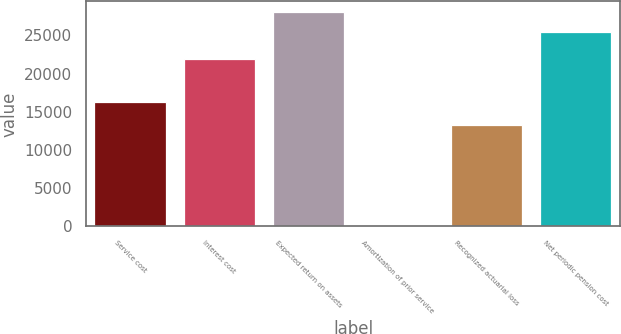<chart> <loc_0><loc_0><loc_500><loc_500><bar_chart><fcel>Service cost<fcel>Interest cost<fcel>Expected return on assets<fcel>Amortization of prior service<fcel>Recognized actuarial loss<fcel>Net periodic pension cost<nl><fcel>16231<fcel>21850<fcel>28022.2<fcel>192<fcel>13322<fcel>25467<nl></chart> 